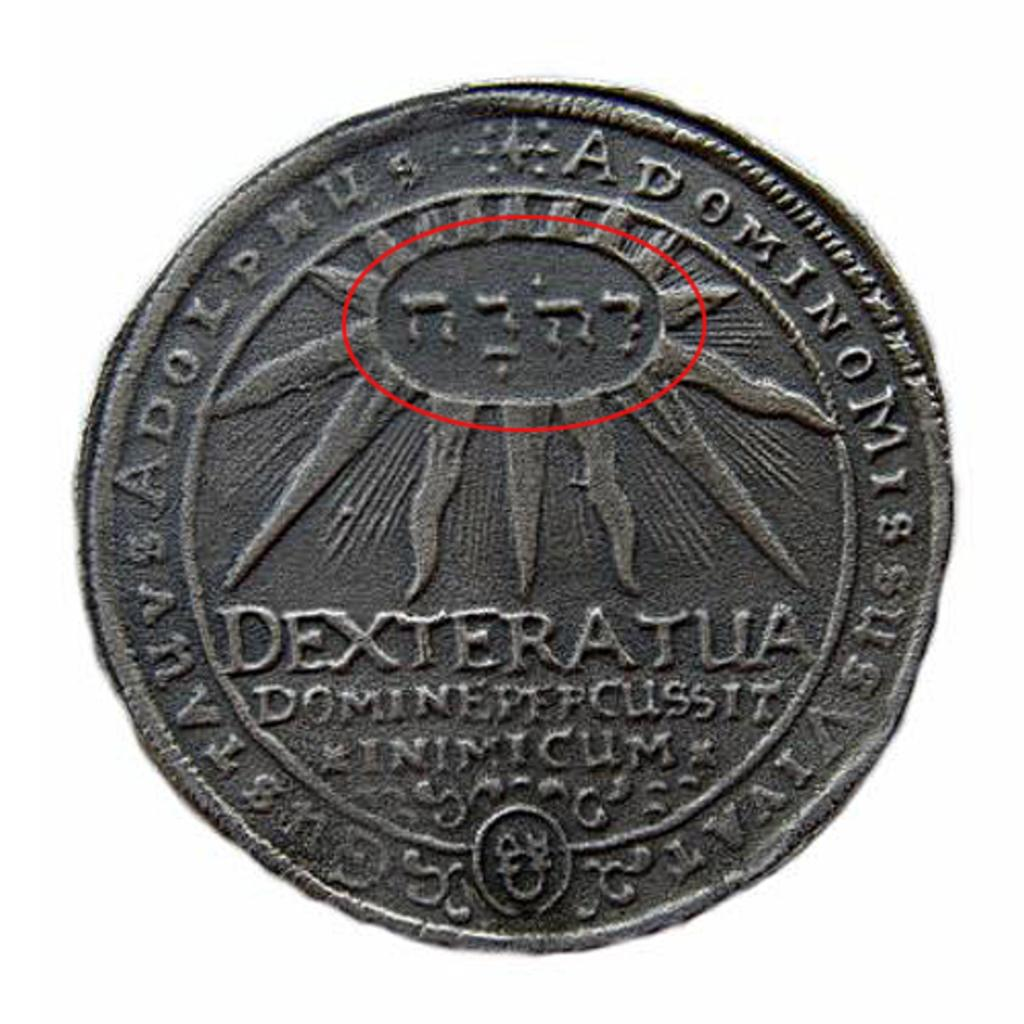<image>
Share a concise interpretation of the image provided. Silver coin with sunburst and with Dexteratua Dominepepcussit Inimicum and Adoninomi 